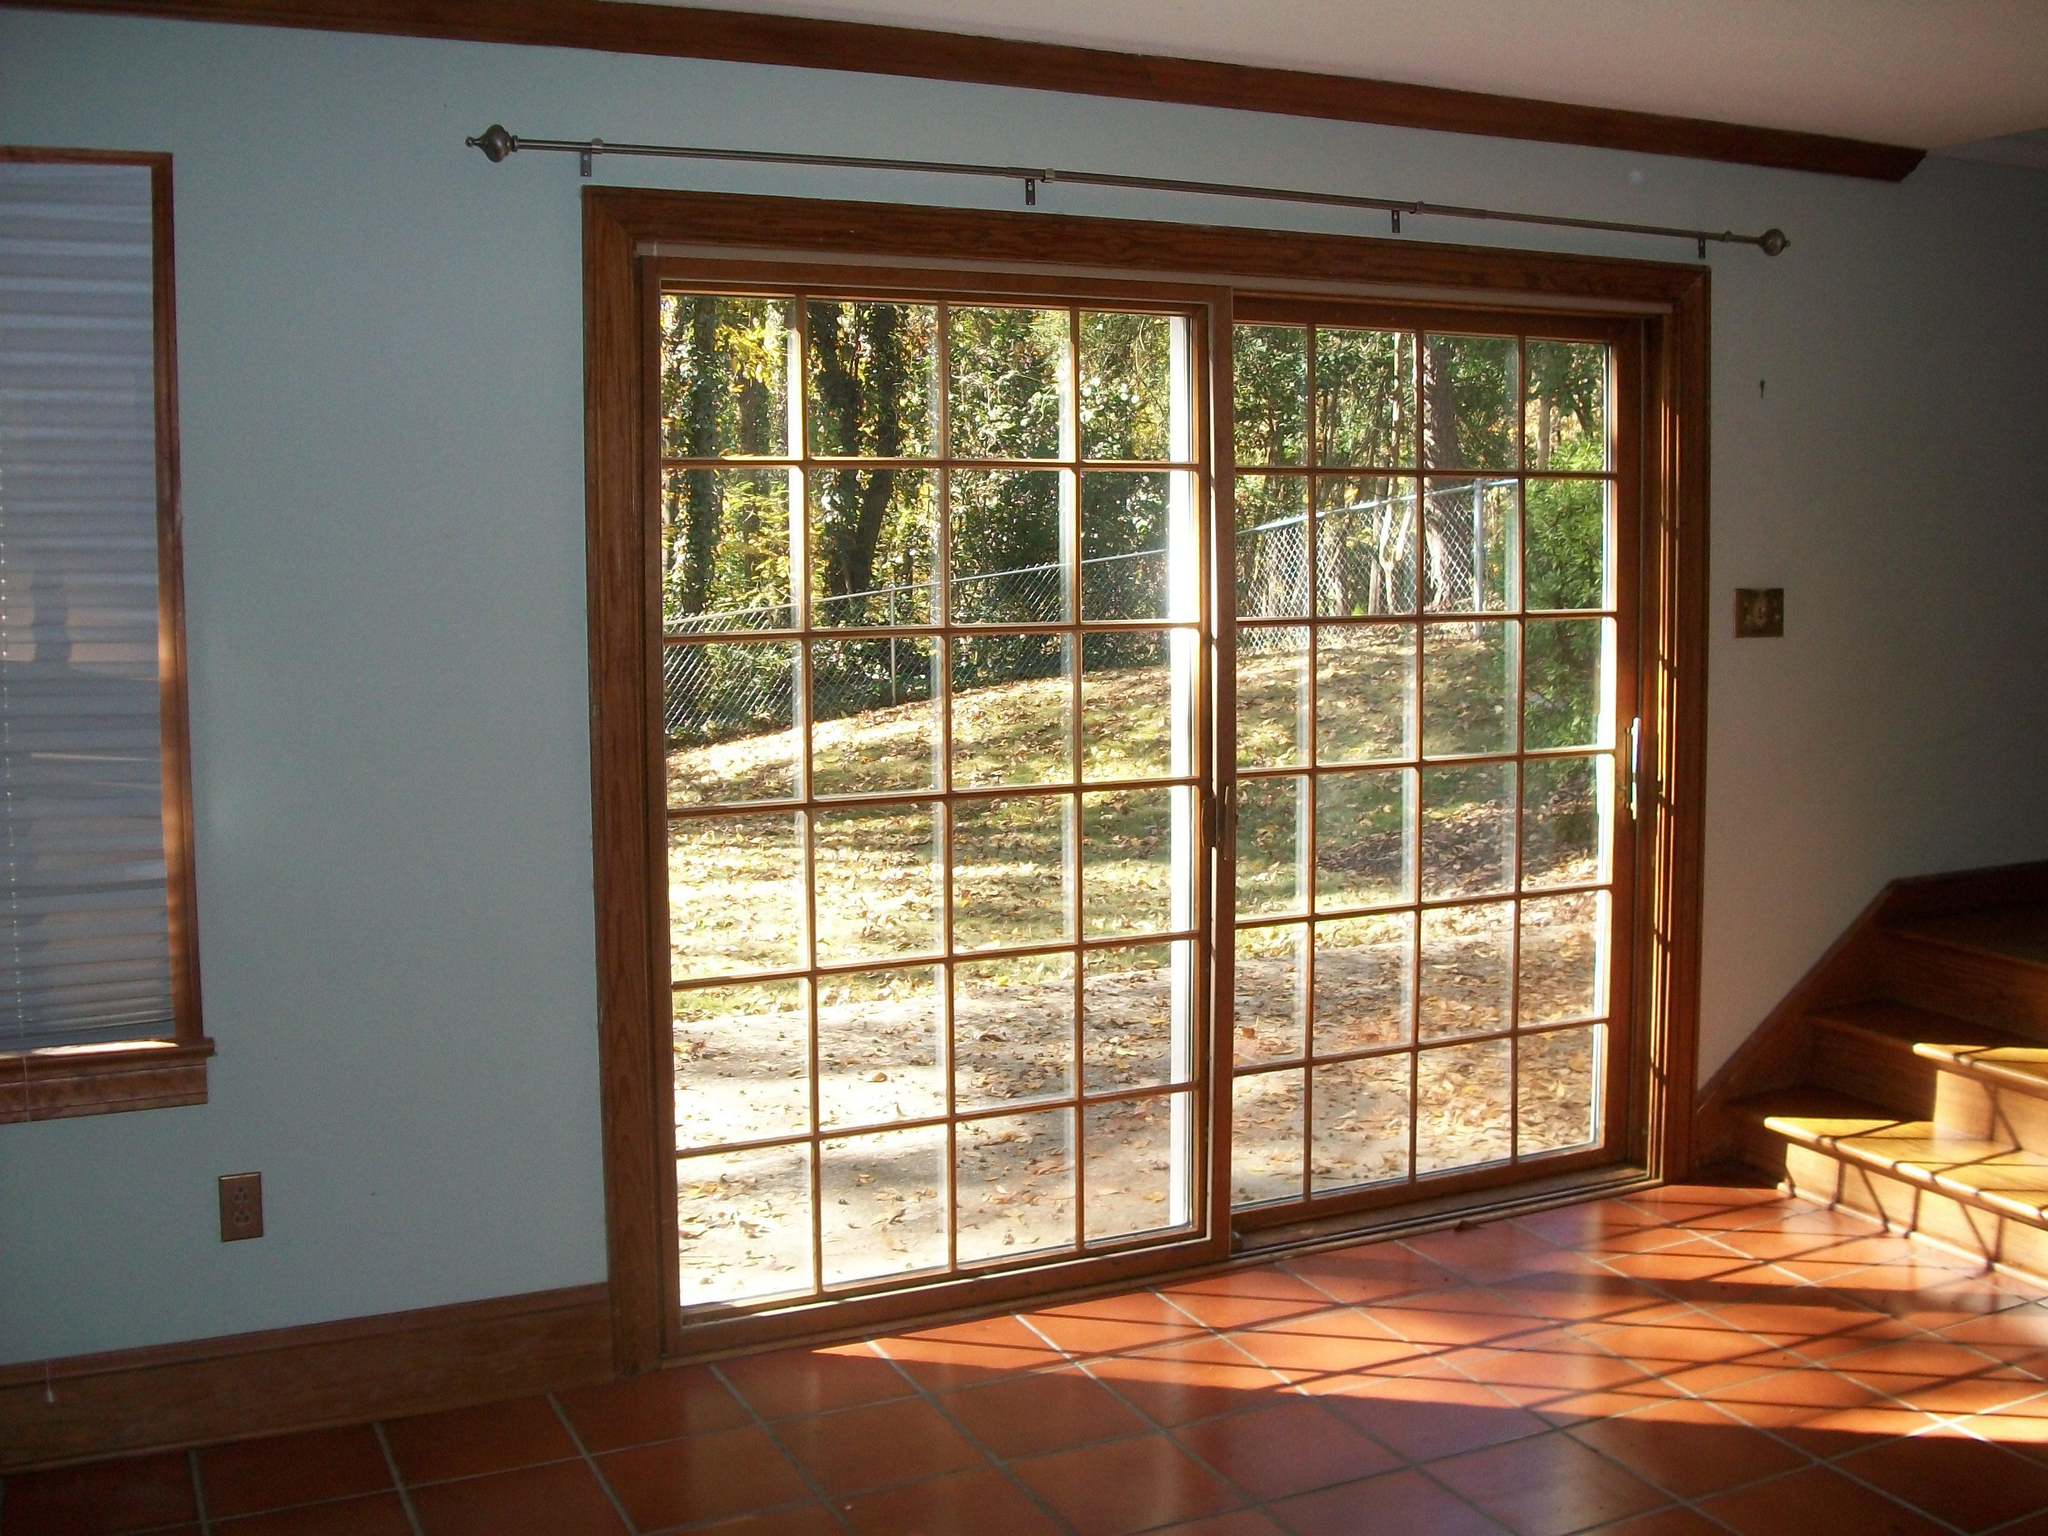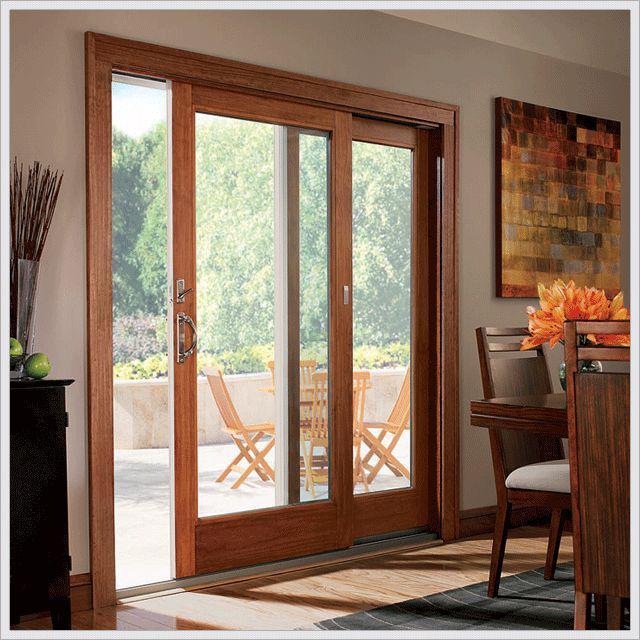The first image is the image on the left, the second image is the image on the right. For the images shown, is this caption "There is a flower vase on top of a table near a sliding door." true? Answer yes or no. Yes. The first image is the image on the left, the second image is the image on the right. Given the left and right images, does the statement "An image shows a nearly square sliding door unit, with one door partly open, less than a quarter of the way." hold true? Answer yes or no. Yes. 